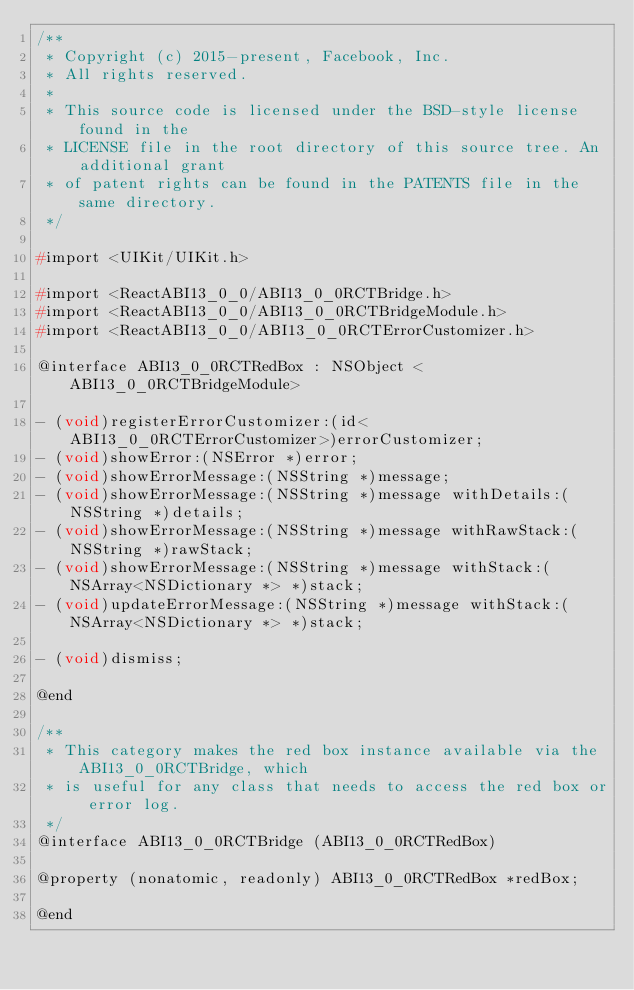Convert code to text. <code><loc_0><loc_0><loc_500><loc_500><_C_>/**
 * Copyright (c) 2015-present, Facebook, Inc.
 * All rights reserved.
 *
 * This source code is licensed under the BSD-style license found in the
 * LICENSE file in the root directory of this source tree. An additional grant
 * of patent rights can be found in the PATENTS file in the same directory.
 */

#import <UIKit/UIKit.h>

#import <ReactABI13_0_0/ABI13_0_0RCTBridge.h>
#import <ReactABI13_0_0/ABI13_0_0RCTBridgeModule.h>
#import <ReactABI13_0_0/ABI13_0_0RCTErrorCustomizer.h>

@interface ABI13_0_0RCTRedBox : NSObject <ABI13_0_0RCTBridgeModule>

- (void)registerErrorCustomizer:(id<ABI13_0_0RCTErrorCustomizer>)errorCustomizer;
- (void)showError:(NSError *)error;
- (void)showErrorMessage:(NSString *)message;
- (void)showErrorMessage:(NSString *)message withDetails:(NSString *)details;
- (void)showErrorMessage:(NSString *)message withRawStack:(NSString *)rawStack;
- (void)showErrorMessage:(NSString *)message withStack:(NSArray<NSDictionary *> *)stack;
- (void)updateErrorMessage:(NSString *)message withStack:(NSArray<NSDictionary *> *)stack;

- (void)dismiss;

@end

/**
 * This category makes the red box instance available via the ABI13_0_0RCTBridge, which
 * is useful for any class that needs to access the red box or error log.
 */
@interface ABI13_0_0RCTBridge (ABI13_0_0RCTRedBox)

@property (nonatomic, readonly) ABI13_0_0RCTRedBox *redBox;

@end
</code> 